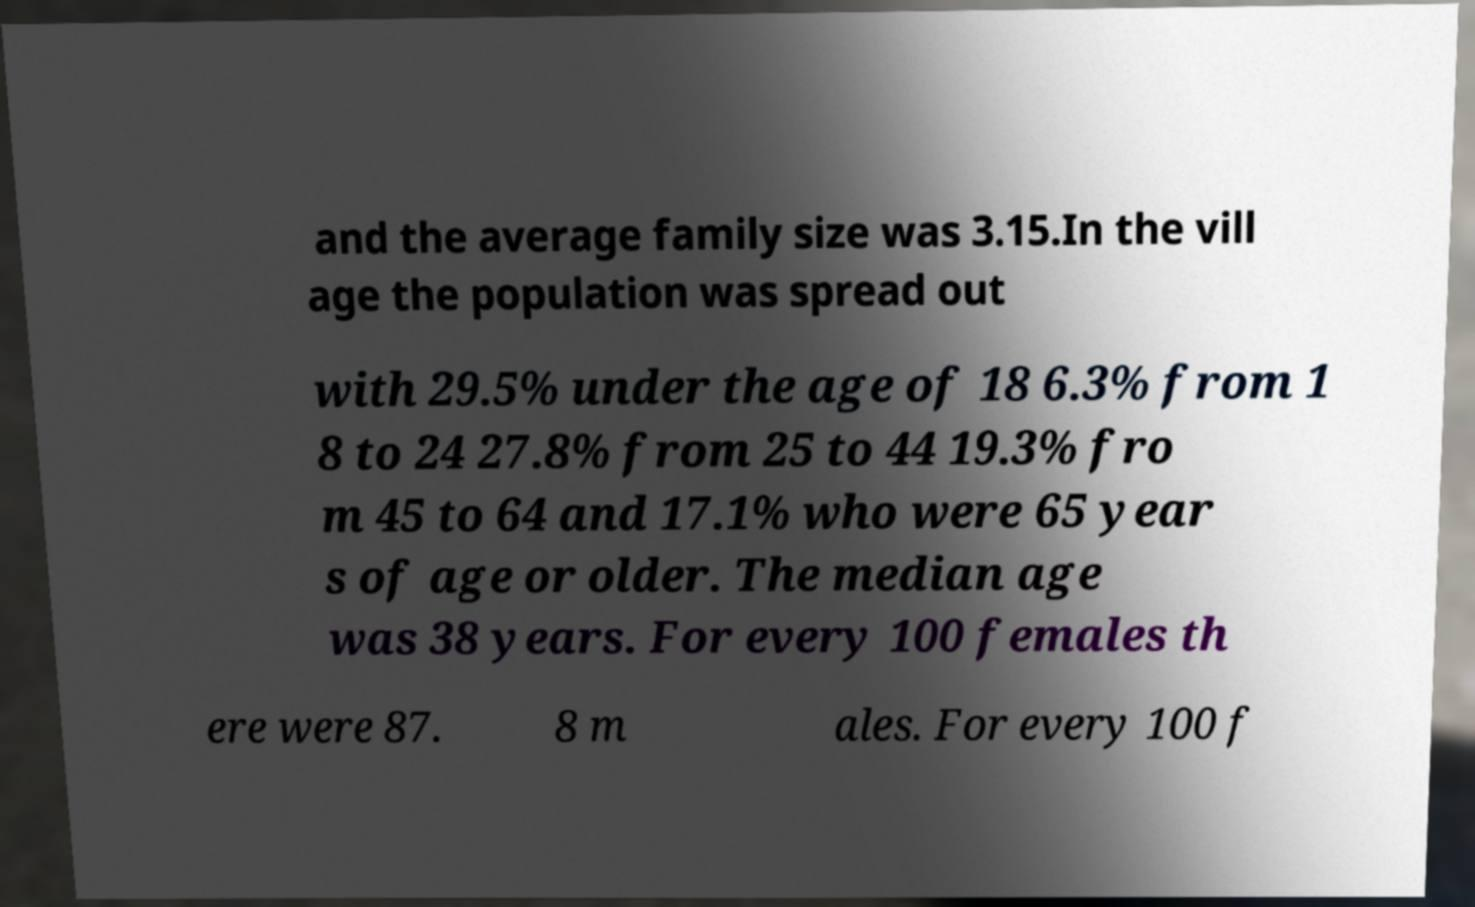There's text embedded in this image that I need extracted. Can you transcribe it verbatim? and the average family size was 3.15.In the vill age the population was spread out with 29.5% under the age of 18 6.3% from 1 8 to 24 27.8% from 25 to 44 19.3% fro m 45 to 64 and 17.1% who were 65 year s of age or older. The median age was 38 years. For every 100 females th ere were 87. 8 m ales. For every 100 f 